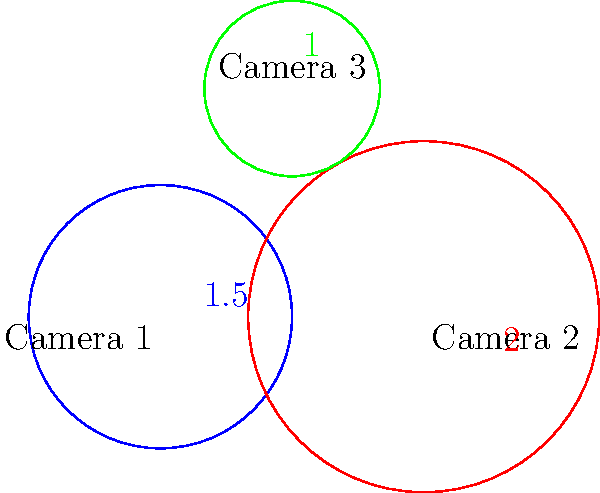You're tasked with comparing the coverage areas of three security cameras. The image shows three circles representing the coverage areas of Camera 1 (blue), Camera 2 (red), and Camera 3 (green). The numbers indicate the radius of each circle in some unit of measurement. Which camera has the largest coverage area? To determine which camera has the largest coverage area, we need to compare the areas of the circles. The area of a circle is calculated using the formula $A = \pi r^2$, where $r$ is the radius.

Let's calculate the area for each camera:

1. Camera 1 (blue):
   Radius = 1.5
   Area = $\pi (1.5)^2 = 2.25\pi$

2. Camera 2 (red):
   Radius = 2
   Area = $\pi (2)^2 = 4\pi$

3. Camera 3 (green):
   Radius = 1
   Area = $\pi (1)^2 = \pi$

Comparing the areas:
Camera 1: $2.25\pi$
Camera 2: $4\pi$
Camera 3: $\pi$

Camera 2 has the largest area at $4\pi$, which is greater than both Camera 1 ($2.25\pi$) and Camera 3 ($\pi$).
Answer: Camera 2 (red) 